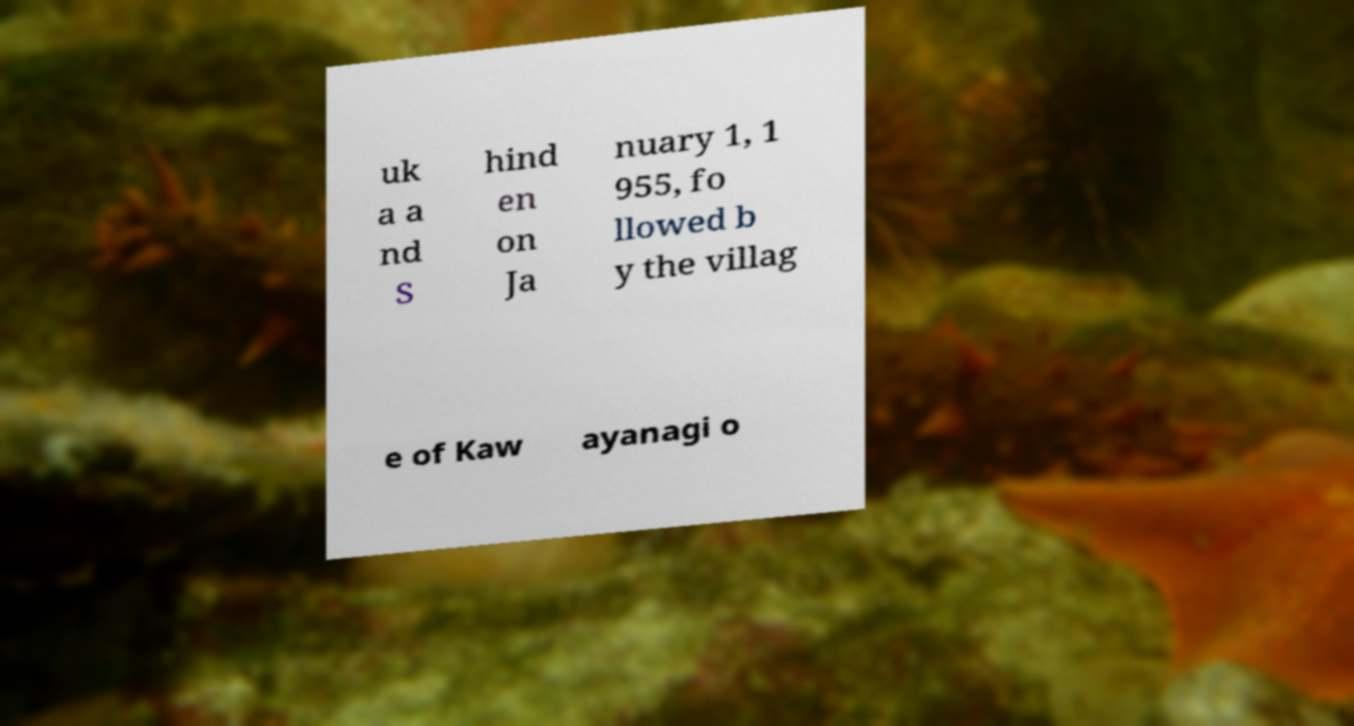There's text embedded in this image that I need extracted. Can you transcribe it verbatim? uk a a nd S hind en on Ja nuary 1, 1 955, fo llowed b y the villag e of Kaw ayanagi o 